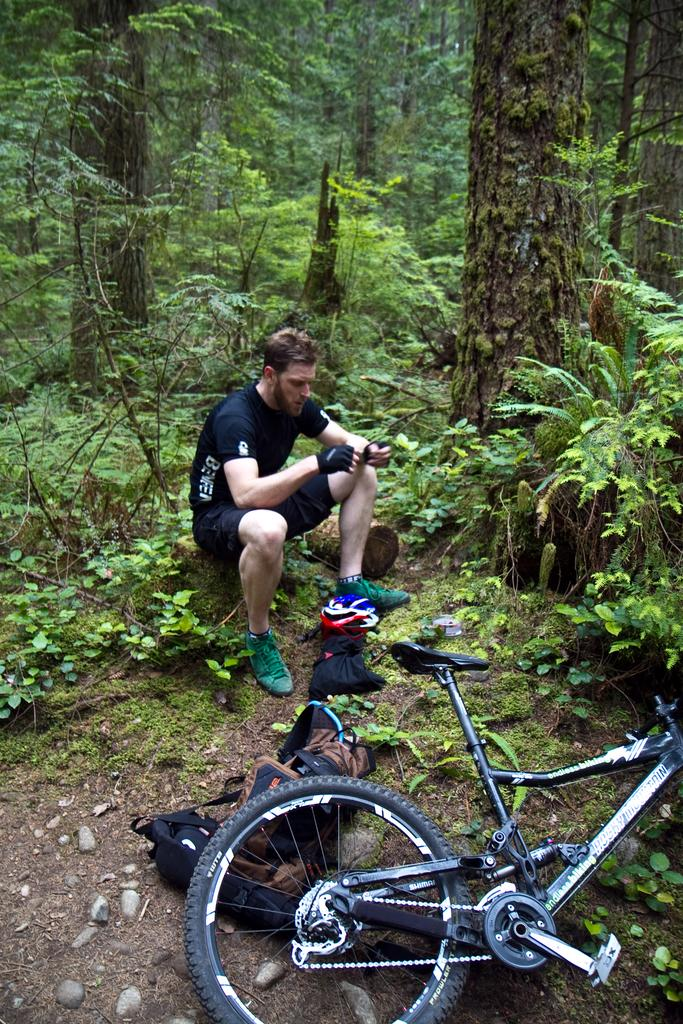What object is on the ground in the image? There is a bicycle on the ground in the image. What else is on the ground in the image? There is a bag on the ground in the image. What is the person in the image doing? The person is sitting on a wooden log in the image. What can be seen in the background of the image? There are many trees and plants in the background of the image. What type of haircut does the person in the image have? There is no information about the person's haircut in the image. What scene is depicted in the image? The image shows a person sitting on a wooden log, with a bicycle and a bag on the ground, and trees and plants in the background. 